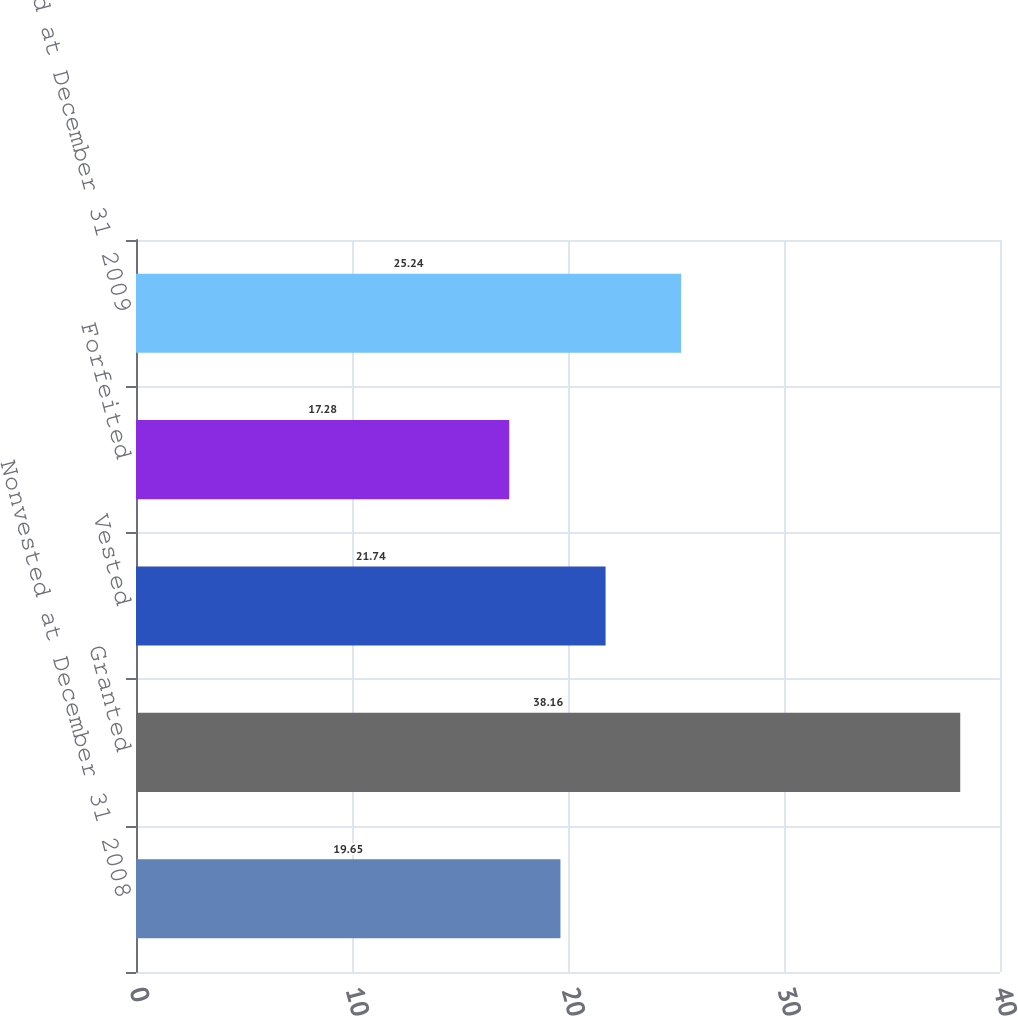<chart> <loc_0><loc_0><loc_500><loc_500><bar_chart><fcel>Nonvested at December 31 2008<fcel>Granted<fcel>Vested<fcel>Forfeited<fcel>Nonvested at December 31 2009<nl><fcel>19.65<fcel>38.16<fcel>21.74<fcel>17.28<fcel>25.24<nl></chart> 